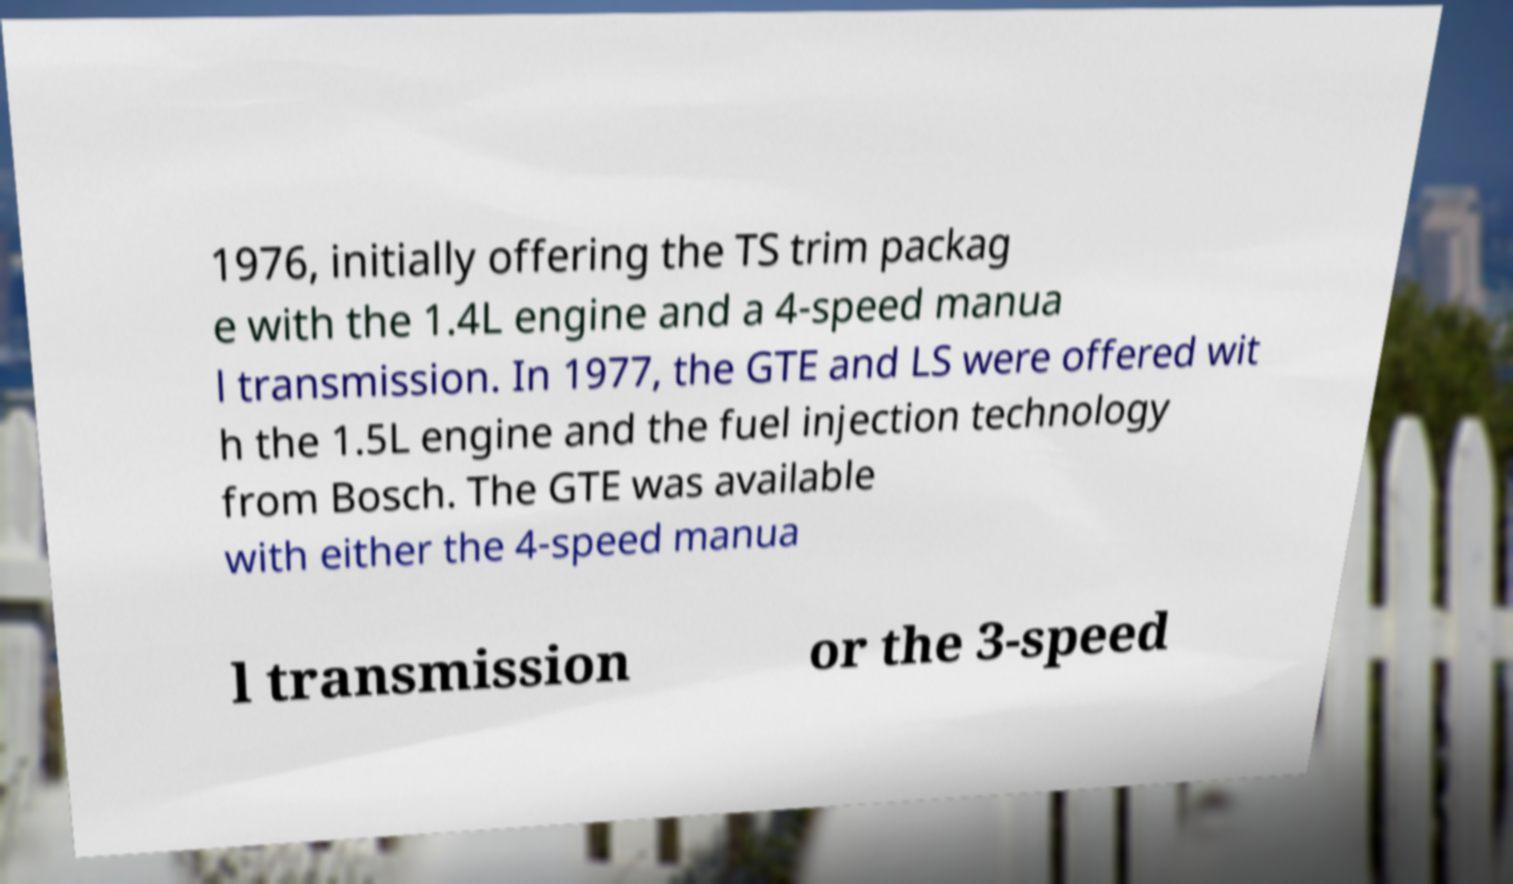Can you read and provide the text displayed in the image?This photo seems to have some interesting text. Can you extract and type it out for me? 1976, initially offering the TS trim packag e with the 1.4L engine and a 4-speed manua l transmission. In 1977, the GTE and LS were offered wit h the 1.5L engine and the fuel injection technology from Bosch. The GTE was available with either the 4-speed manua l transmission or the 3-speed 